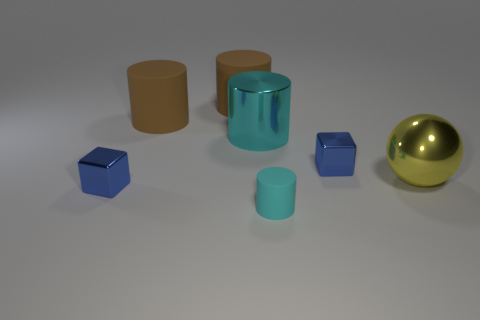There is a cyan object in front of the yellow ball that is on the right side of the small cube in front of the sphere; what is its material?
Provide a short and direct response. Rubber. What number of other objects are the same material as the large yellow ball?
Make the answer very short. 3. There is a small blue object on the right side of the tiny cyan matte object; how many small blue cubes are on the left side of it?
Your response must be concise. 1. What number of cylinders are blue objects or large things?
Your response must be concise. 3. What is the color of the thing that is behind the tiny cyan cylinder and in front of the yellow metallic sphere?
Ensure brevity in your answer.  Blue. Is there anything else that has the same color as the large sphere?
Provide a short and direct response. No. The small thing that is behind the yellow object right of the shiny cylinder is what color?
Offer a terse response. Blue. Do the cyan shiny cylinder and the metallic ball have the same size?
Your response must be concise. Yes. Does the blue cube on the left side of the cyan shiny cylinder have the same material as the cyan object in front of the large yellow object?
Offer a terse response. No. What shape is the tiny matte thing to the left of the shiny cube behind the tiny blue thing that is in front of the yellow sphere?
Offer a terse response. Cylinder. 